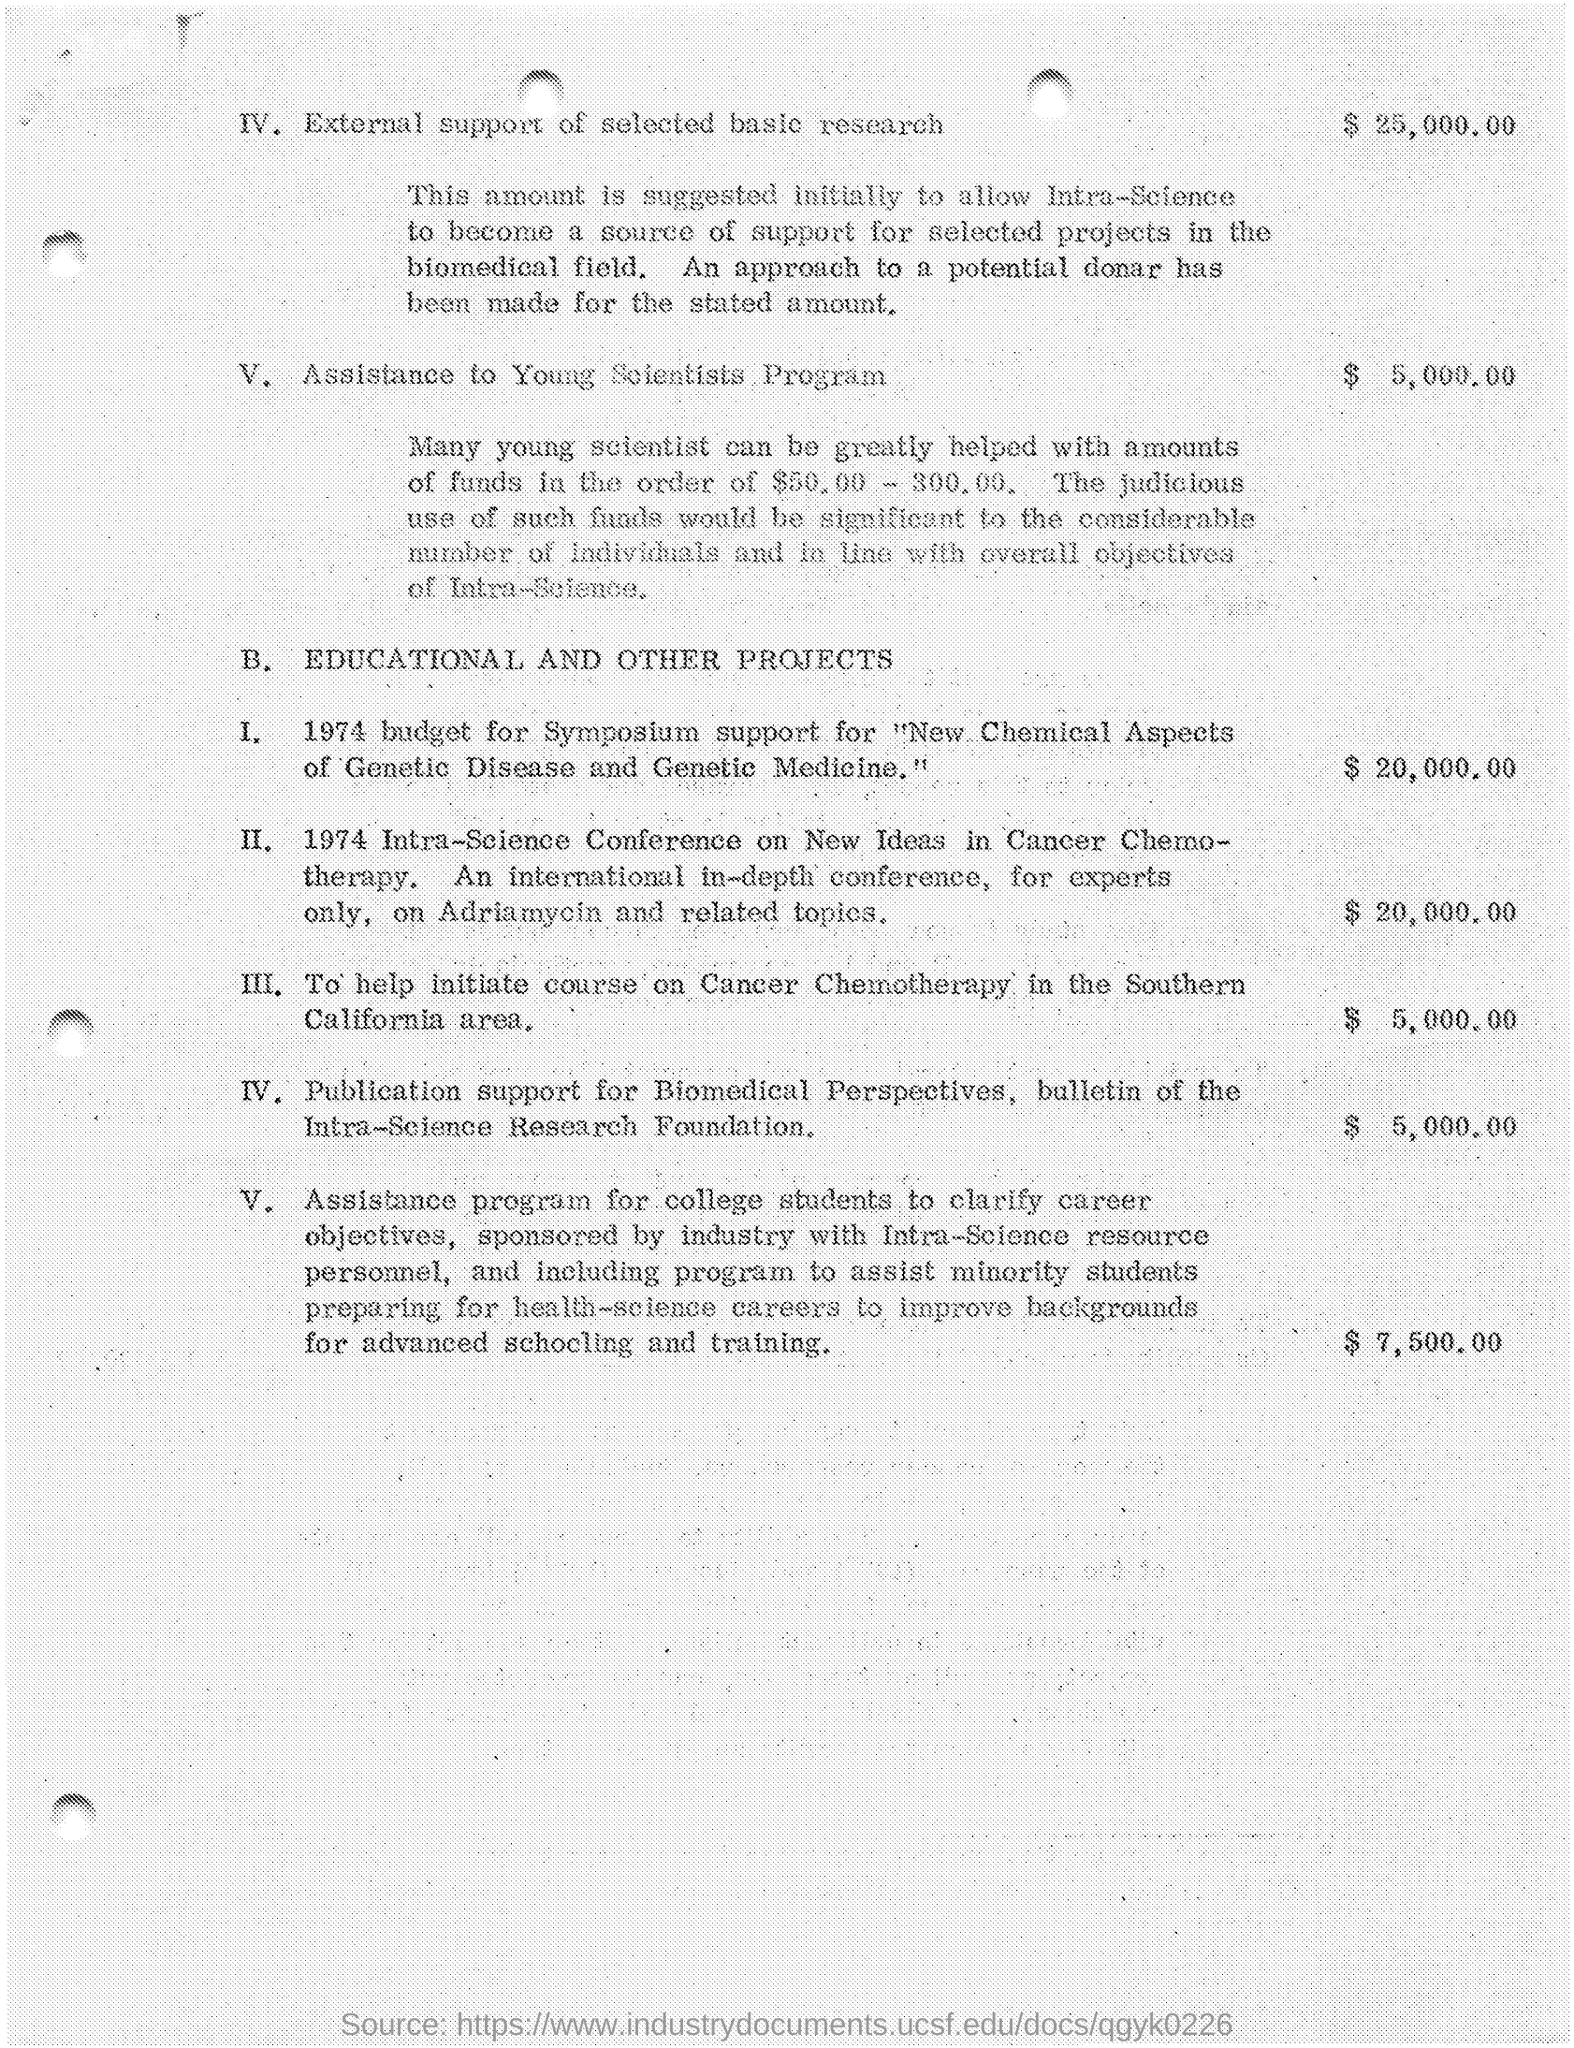List a handful of essential elements in this visual. It is estimated that the amount given for initiating a course on cancer chemotherapy in the Southern California area is $5,000.00. The amount provided for publication support in the Biomedical Perspectives bulletin of the Intra-Science Research Foundation is $5,000.00. The amount provided for the Assistance to Young Scientists program is $5,000.00. The amount allocated for symposium support in the 1974 budget was $20,000.00. The amount given for the 1974 Intra-Science Conference on New Ideas in Cancer Chemotherapy was $20,000.00. 